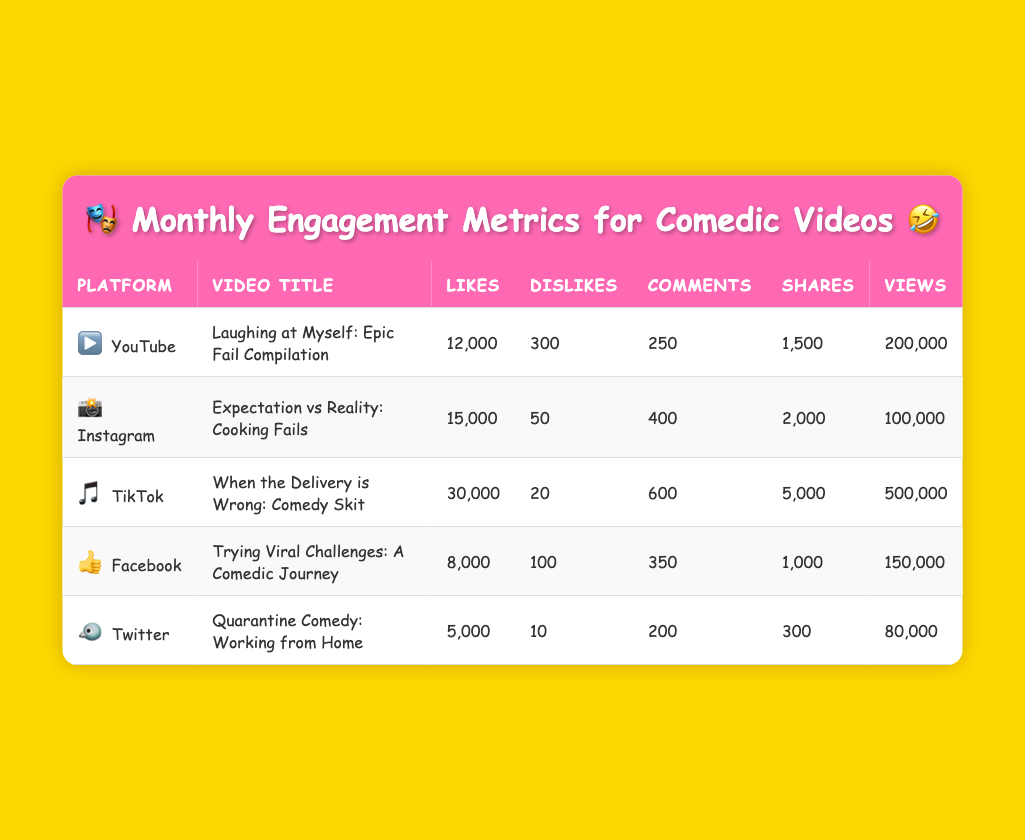What is the total number of likes across all platforms? To find the total number of likes, we add the likes from each platform: 12000 (YouTube) + 15000 (Instagram) + 30000 (TikTok) + 8000 (Facebook) + 5000 (Twitter) = 70000.
Answer: 70000 Which video received the highest number of dislikes? By examining the dislikes for each video, we find: YouTube has 300, Instagram has 50, TikTok has 20, Facebook has 100, and Twitter has 10. The highest is 300 dislikes for the YouTube video.
Answer: YouTube What is the average number of comments for the videos? We add up the comments: 250 (YouTube) + 400 (Instagram) + 600 (TikTok) + 350 (Facebook) + 200 (Twitter) = 1800. Then, we divide by the number of videos (5): 1800 / 5 = 360.
Answer: 360 Is the total number of shares for TikTok higher than the total number of shares for the other platforms combined? TikTok has 5000 shares. Adding the shares from the others, we get 1500 (YouTube) + 2000 (Instagram) + 1000 (Facebook) + 300 (Twitter) = 4800. Since 5000 > 4800, Tiktok has more shares.
Answer: Yes Which platform has the least number of views? The views across platforms are: YouTube has 200000, Instagram has 100000, TikTok has 500000, Facebook has 150000, and Twitter has 80000. The lowest is 80000 from Twitter.
Answer: Twitter 